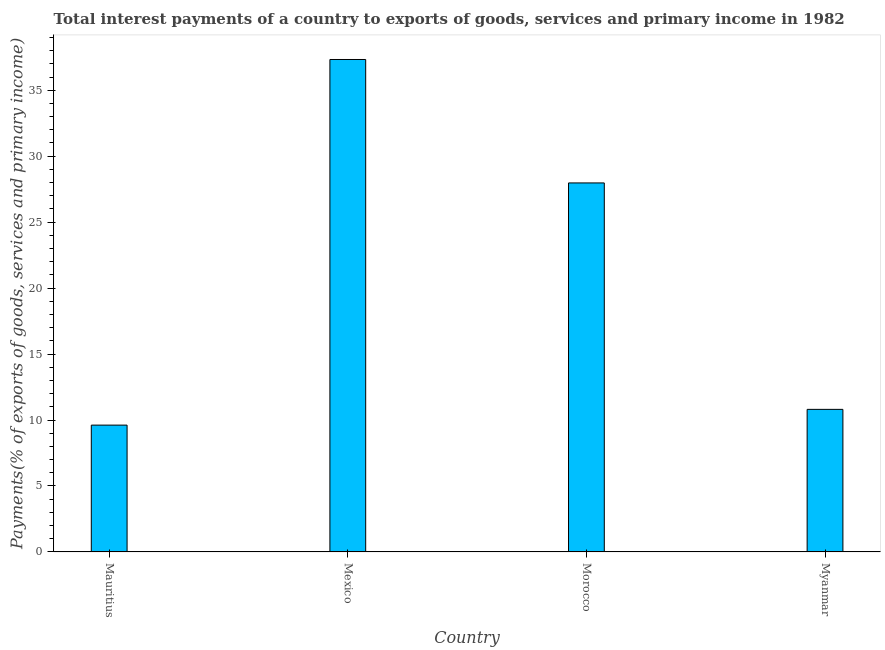What is the title of the graph?
Make the answer very short. Total interest payments of a country to exports of goods, services and primary income in 1982. What is the label or title of the X-axis?
Ensure brevity in your answer.  Country. What is the label or title of the Y-axis?
Your response must be concise. Payments(% of exports of goods, services and primary income). What is the total interest payments on external debt in Mauritius?
Give a very brief answer. 9.61. Across all countries, what is the maximum total interest payments on external debt?
Ensure brevity in your answer.  37.33. Across all countries, what is the minimum total interest payments on external debt?
Offer a terse response. 9.61. In which country was the total interest payments on external debt maximum?
Keep it short and to the point. Mexico. In which country was the total interest payments on external debt minimum?
Make the answer very short. Mauritius. What is the sum of the total interest payments on external debt?
Provide a succinct answer. 85.72. What is the difference between the total interest payments on external debt in Mauritius and Myanmar?
Ensure brevity in your answer.  -1.19. What is the average total interest payments on external debt per country?
Your answer should be compact. 21.43. What is the median total interest payments on external debt?
Your response must be concise. 19.39. What is the ratio of the total interest payments on external debt in Mauritius to that in Myanmar?
Keep it short and to the point. 0.89. What is the difference between the highest and the second highest total interest payments on external debt?
Ensure brevity in your answer.  9.36. Is the sum of the total interest payments on external debt in Mexico and Myanmar greater than the maximum total interest payments on external debt across all countries?
Keep it short and to the point. Yes. What is the difference between the highest and the lowest total interest payments on external debt?
Offer a terse response. 27.71. In how many countries, is the total interest payments on external debt greater than the average total interest payments on external debt taken over all countries?
Give a very brief answer. 2. Are all the bars in the graph horizontal?
Offer a very short reply. No. How many countries are there in the graph?
Offer a very short reply. 4. What is the difference between two consecutive major ticks on the Y-axis?
Your response must be concise. 5. What is the Payments(% of exports of goods, services and primary income) of Mauritius?
Keep it short and to the point. 9.61. What is the Payments(% of exports of goods, services and primary income) of Mexico?
Make the answer very short. 37.33. What is the Payments(% of exports of goods, services and primary income) of Morocco?
Give a very brief answer. 27.97. What is the Payments(% of exports of goods, services and primary income) of Myanmar?
Offer a terse response. 10.81. What is the difference between the Payments(% of exports of goods, services and primary income) in Mauritius and Mexico?
Your answer should be very brief. -27.71. What is the difference between the Payments(% of exports of goods, services and primary income) in Mauritius and Morocco?
Your answer should be compact. -18.36. What is the difference between the Payments(% of exports of goods, services and primary income) in Mauritius and Myanmar?
Offer a terse response. -1.19. What is the difference between the Payments(% of exports of goods, services and primary income) in Mexico and Morocco?
Your answer should be very brief. 9.36. What is the difference between the Payments(% of exports of goods, services and primary income) in Mexico and Myanmar?
Offer a very short reply. 26.52. What is the difference between the Payments(% of exports of goods, services and primary income) in Morocco and Myanmar?
Provide a short and direct response. 17.16. What is the ratio of the Payments(% of exports of goods, services and primary income) in Mauritius to that in Mexico?
Keep it short and to the point. 0.26. What is the ratio of the Payments(% of exports of goods, services and primary income) in Mauritius to that in Morocco?
Your answer should be compact. 0.34. What is the ratio of the Payments(% of exports of goods, services and primary income) in Mauritius to that in Myanmar?
Your answer should be very brief. 0.89. What is the ratio of the Payments(% of exports of goods, services and primary income) in Mexico to that in Morocco?
Make the answer very short. 1.33. What is the ratio of the Payments(% of exports of goods, services and primary income) in Mexico to that in Myanmar?
Your answer should be compact. 3.45. What is the ratio of the Payments(% of exports of goods, services and primary income) in Morocco to that in Myanmar?
Your answer should be very brief. 2.59. 